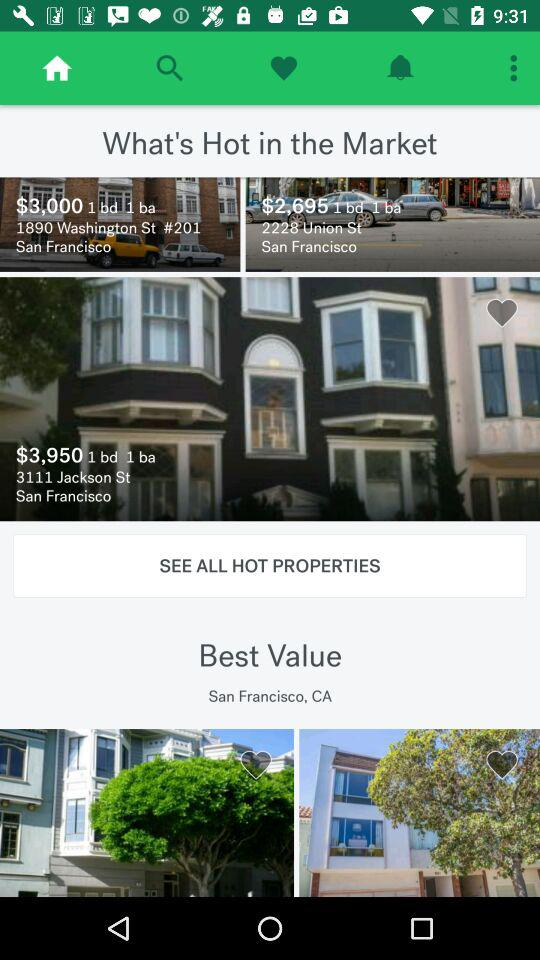What is the address of the property listed at $2,695? The address is 2228 Union St., San Francisco. 